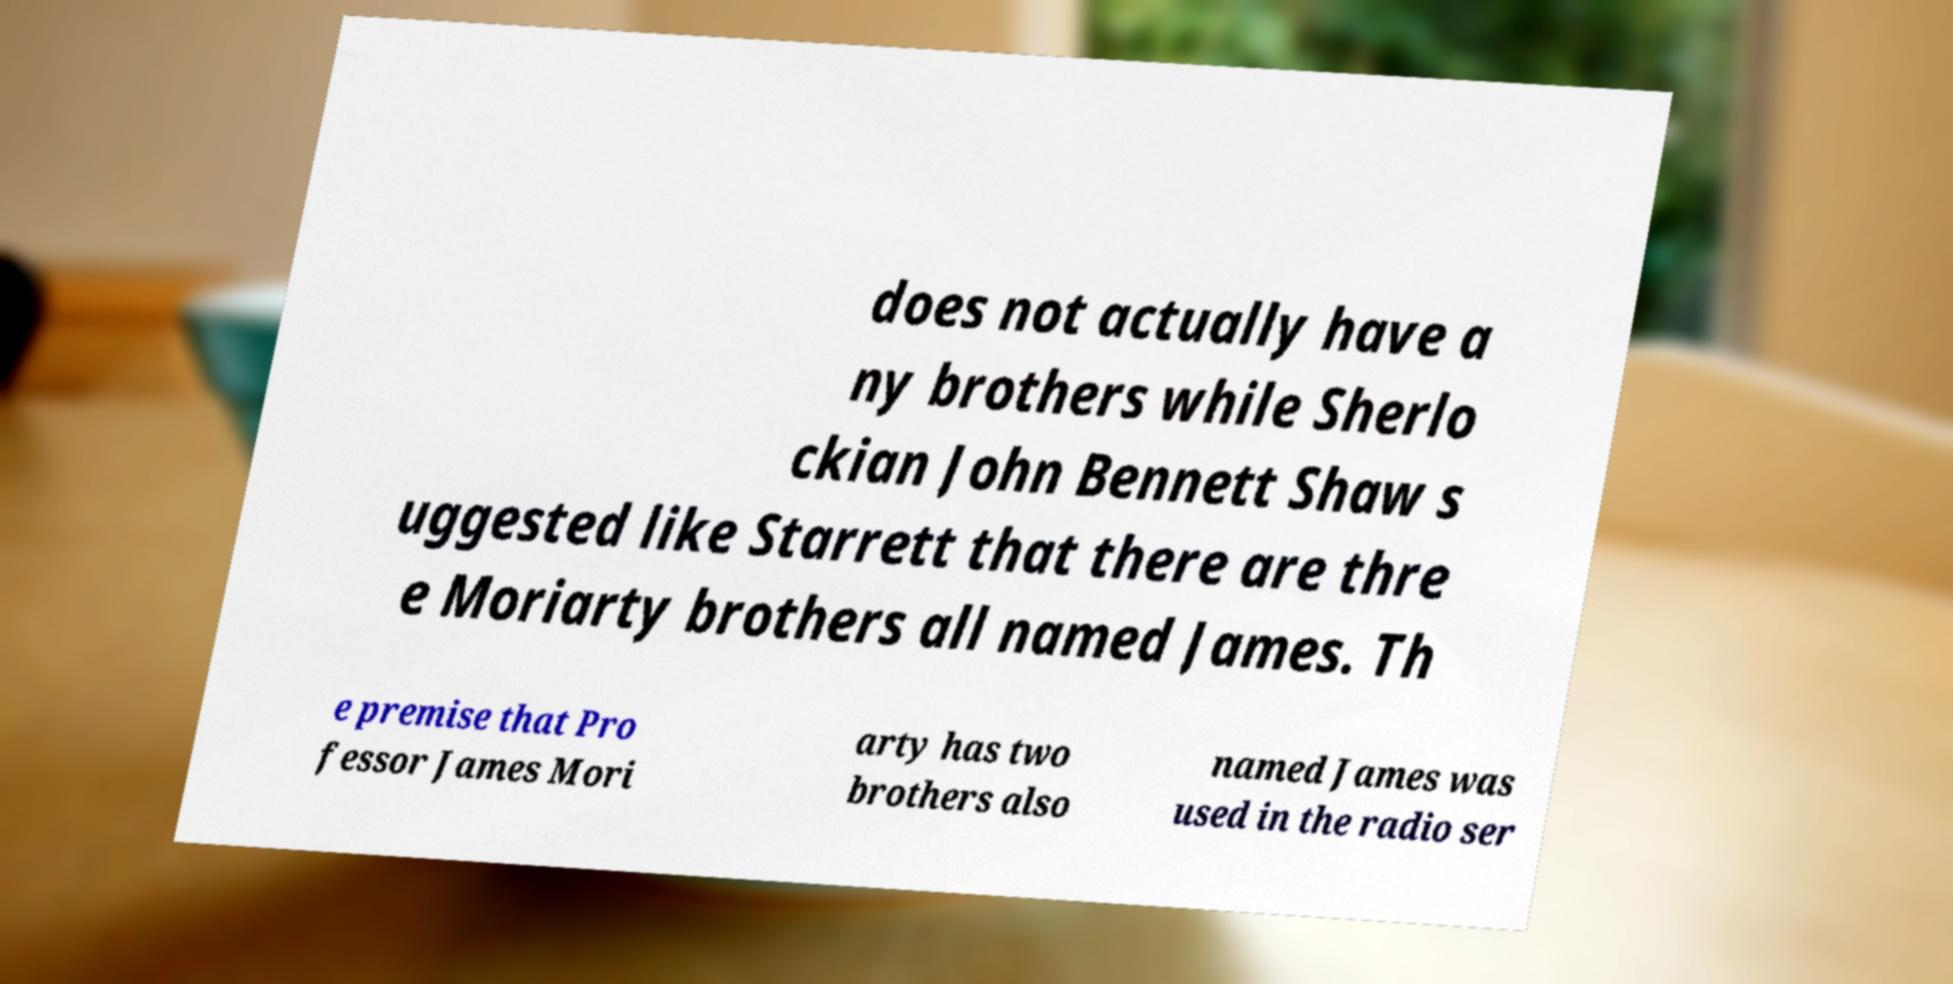Please read and relay the text visible in this image. What does it say? does not actually have a ny brothers while Sherlo ckian John Bennett Shaw s uggested like Starrett that there are thre e Moriarty brothers all named James. Th e premise that Pro fessor James Mori arty has two brothers also named James was used in the radio ser 